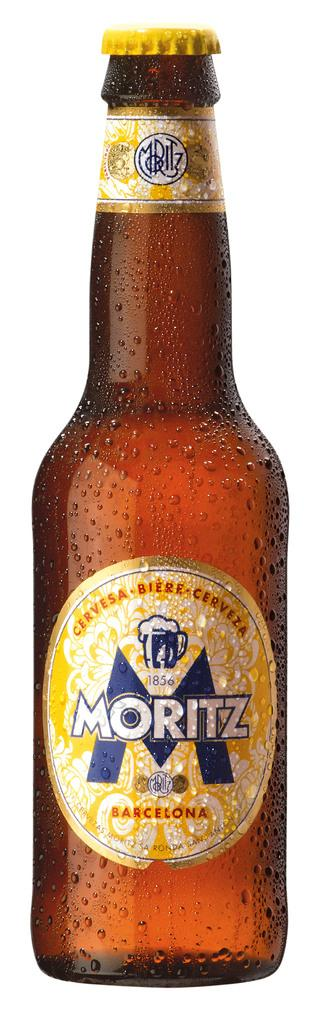<image>
Present a compact description of the photo's key features. A brown beer bottle with a label named MORITZ. 